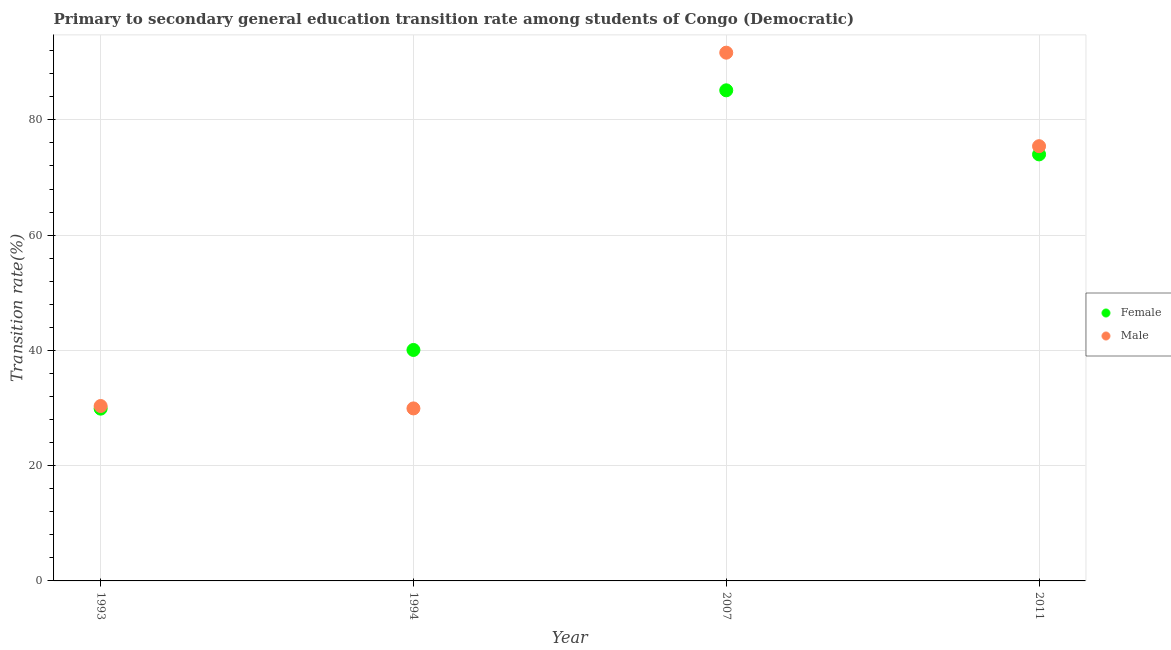How many different coloured dotlines are there?
Provide a succinct answer. 2. Is the number of dotlines equal to the number of legend labels?
Make the answer very short. Yes. What is the transition rate among male students in 1993?
Offer a terse response. 30.35. Across all years, what is the maximum transition rate among female students?
Offer a very short reply. 85.13. Across all years, what is the minimum transition rate among male students?
Provide a succinct answer. 29.93. In which year was the transition rate among female students maximum?
Your answer should be compact. 2007. What is the total transition rate among female students in the graph?
Make the answer very short. 229.11. What is the difference between the transition rate among male students in 2007 and that in 2011?
Ensure brevity in your answer.  16.23. What is the difference between the transition rate among female students in 2007 and the transition rate among male students in 1994?
Give a very brief answer. 55.2. What is the average transition rate among male students per year?
Give a very brief answer. 56.85. In the year 2011, what is the difference between the transition rate among female students and transition rate among male students?
Your answer should be compact. -1.43. What is the ratio of the transition rate among male students in 1993 to that in 2007?
Provide a short and direct response. 0.33. Is the transition rate among female students in 1993 less than that in 2007?
Your response must be concise. Yes. What is the difference between the highest and the second highest transition rate among female students?
Offer a terse response. 11.12. What is the difference between the highest and the lowest transition rate among female students?
Offer a terse response. 55.24. In how many years, is the transition rate among female students greater than the average transition rate among female students taken over all years?
Keep it short and to the point. 2. Does the transition rate among male students monotonically increase over the years?
Keep it short and to the point. No. Is the transition rate among female students strictly less than the transition rate among male students over the years?
Provide a short and direct response. No. Does the graph contain any zero values?
Keep it short and to the point. No. How are the legend labels stacked?
Make the answer very short. Vertical. What is the title of the graph?
Offer a terse response. Primary to secondary general education transition rate among students of Congo (Democratic). What is the label or title of the Y-axis?
Ensure brevity in your answer.  Transition rate(%). What is the Transition rate(%) in Female in 1993?
Ensure brevity in your answer.  29.89. What is the Transition rate(%) in Male in 1993?
Your answer should be very brief. 30.35. What is the Transition rate(%) in Female in 1994?
Your answer should be very brief. 40.08. What is the Transition rate(%) in Male in 1994?
Provide a succinct answer. 29.93. What is the Transition rate(%) in Female in 2007?
Provide a succinct answer. 85.13. What is the Transition rate(%) in Male in 2007?
Your answer should be compact. 91.66. What is the Transition rate(%) in Female in 2011?
Offer a very short reply. 74.01. What is the Transition rate(%) of Male in 2011?
Give a very brief answer. 75.44. Across all years, what is the maximum Transition rate(%) of Female?
Offer a terse response. 85.13. Across all years, what is the maximum Transition rate(%) of Male?
Offer a very short reply. 91.66. Across all years, what is the minimum Transition rate(%) of Female?
Ensure brevity in your answer.  29.89. Across all years, what is the minimum Transition rate(%) of Male?
Your answer should be compact. 29.93. What is the total Transition rate(%) of Female in the graph?
Keep it short and to the point. 229.11. What is the total Transition rate(%) of Male in the graph?
Offer a terse response. 227.38. What is the difference between the Transition rate(%) in Female in 1993 and that in 1994?
Your answer should be compact. -10.18. What is the difference between the Transition rate(%) of Male in 1993 and that in 1994?
Make the answer very short. 0.42. What is the difference between the Transition rate(%) in Female in 1993 and that in 2007?
Your answer should be very brief. -55.24. What is the difference between the Transition rate(%) of Male in 1993 and that in 2007?
Ensure brevity in your answer.  -61.31. What is the difference between the Transition rate(%) in Female in 1993 and that in 2011?
Provide a succinct answer. -44.12. What is the difference between the Transition rate(%) of Male in 1993 and that in 2011?
Ensure brevity in your answer.  -45.09. What is the difference between the Transition rate(%) of Female in 1994 and that in 2007?
Keep it short and to the point. -45.05. What is the difference between the Transition rate(%) of Male in 1994 and that in 2007?
Keep it short and to the point. -61.73. What is the difference between the Transition rate(%) of Female in 1994 and that in 2011?
Offer a terse response. -33.93. What is the difference between the Transition rate(%) in Male in 1994 and that in 2011?
Provide a short and direct response. -45.5. What is the difference between the Transition rate(%) of Female in 2007 and that in 2011?
Your answer should be very brief. 11.12. What is the difference between the Transition rate(%) in Male in 2007 and that in 2011?
Your response must be concise. 16.23. What is the difference between the Transition rate(%) in Female in 1993 and the Transition rate(%) in Male in 1994?
Provide a succinct answer. -0.04. What is the difference between the Transition rate(%) in Female in 1993 and the Transition rate(%) in Male in 2007?
Keep it short and to the point. -61.77. What is the difference between the Transition rate(%) in Female in 1993 and the Transition rate(%) in Male in 2011?
Your answer should be compact. -45.54. What is the difference between the Transition rate(%) in Female in 1994 and the Transition rate(%) in Male in 2007?
Make the answer very short. -51.59. What is the difference between the Transition rate(%) of Female in 1994 and the Transition rate(%) of Male in 2011?
Provide a succinct answer. -35.36. What is the difference between the Transition rate(%) in Female in 2007 and the Transition rate(%) in Male in 2011?
Provide a short and direct response. 9.69. What is the average Transition rate(%) of Female per year?
Ensure brevity in your answer.  57.28. What is the average Transition rate(%) in Male per year?
Give a very brief answer. 56.85. In the year 1993, what is the difference between the Transition rate(%) in Female and Transition rate(%) in Male?
Ensure brevity in your answer.  -0.46. In the year 1994, what is the difference between the Transition rate(%) of Female and Transition rate(%) of Male?
Your response must be concise. 10.14. In the year 2007, what is the difference between the Transition rate(%) of Female and Transition rate(%) of Male?
Offer a terse response. -6.53. In the year 2011, what is the difference between the Transition rate(%) of Female and Transition rate(%) of Male?
Provide a succinct answer. -1.43. What is the ratio of the Transition rate(%) of Female in 1993 to that in 1994?
Keep it short and to the point. 0.75. What is the ratio of the Transition rate(%) of Male in 1993 to that in 1994?
Offer a very short reply. 1.01. What is the ratio of the Transition rate(%) in Female in 1993 to that in 2007?
Your response must be concise. 0.35. What is the ratio of the Transition rate(%) of Male in 1993 to that in 2007?
Ensure brevity in your answer.  0.33. What is the ratio of the Transition rate(%) of Female in 1993 to that in 2011?
Offer a very short reply. 0.4. What is the ratio of the Transition rate(%) in Male in 1993 to that in 2011?
Offer a terse response. 0.4. What is the ratio of the Transition rate(%) of Female in 1994 to that in 2007?
Keep it short and to the point. 0.47. What is the ratio of the Transition rate(%) in Male in 1994 to that in 2007?
Keep it short and to the point. 0.33. What is the ratio of the Transition rate(%) of Female in 1994 to that in 2011?
Offer a terse response. 0.54. What is the ratio of the Transition rate(%) in Male in 1994 to that in 2011?
Make the answer very short. 0.4. What is the ratio of the Transition rate(%) of Female in 2007 to that in 2011?
Your response must be concise. 1.15. What is the ratio of the Transition rate(%) of Male in 2007 to that in 2011?
Provide a short and direct response. 1.22. What is the difference between the highest and the second highest Transition rate(%) in Female?
Provide a succinct answer. 11.12. What is the difference between the highest and the second highest Transition rate(%) of Male?
Offer a terse response. 16.23. What is the difference between the highest and the lowest Transition rate(%) in Female?
Keep it short and to the point. 55.24. What is the difference between the highest and the lowest Transition rate(%) of Male?
Ensure brevity in your answer.  61.73. 